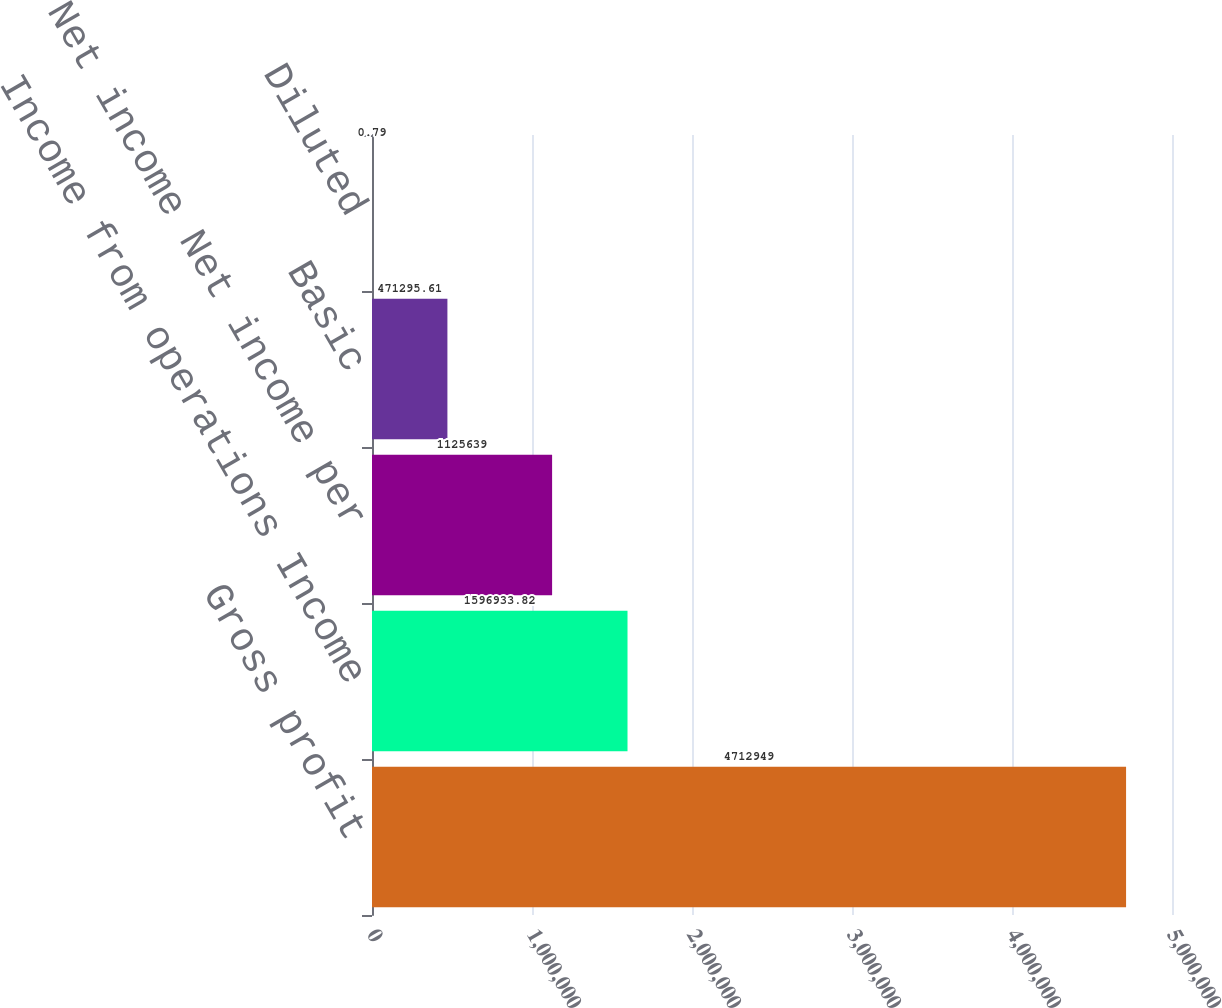Convert chart to OTSL. <chart><loc_0><loc_0><loc_500><loc_500><bar_chart><fcel>Gross profit<fcel>Income from operations Income<fcel>Net income Net income per<fcel>Basic<fcel>Diluted<nl><fcel>4.71295e+06<fcel>1.59693e+06<fcel>1.12564e+06<fcel>471296<fcel>0.79<nl></chart> 